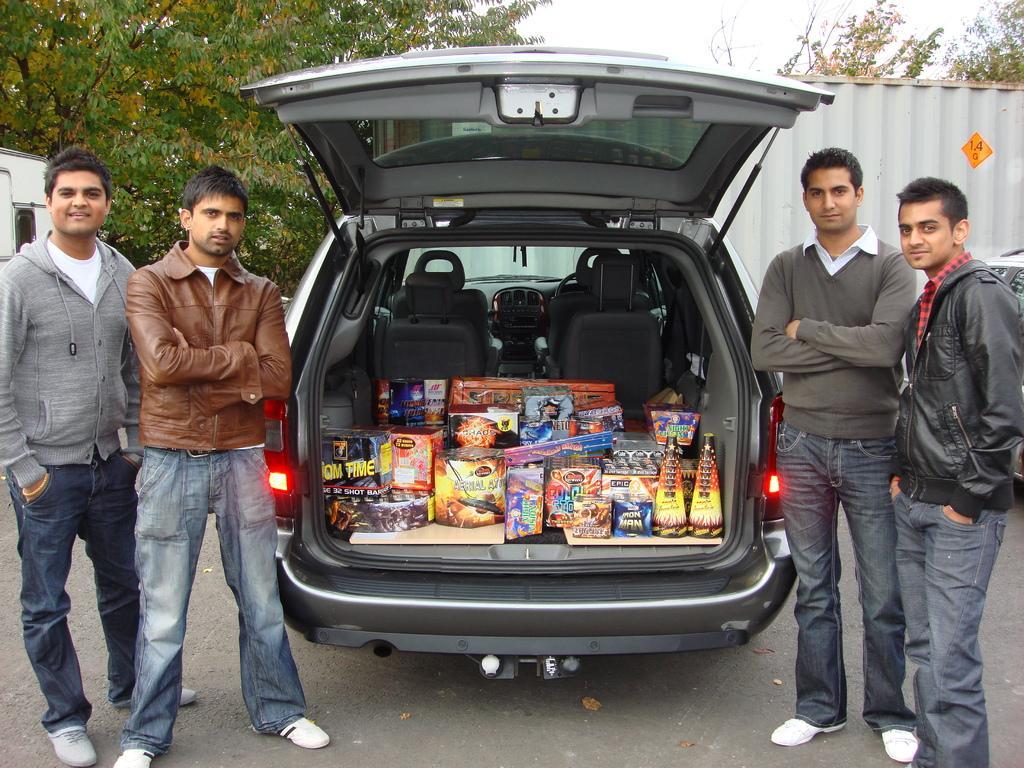In one or two sentences, can you explain what this image depicts? In this image I can see few people standing and wearing different color dresses. I can see few boxes inside the car. Back I can see trees and white color object. The sky is in white color. 